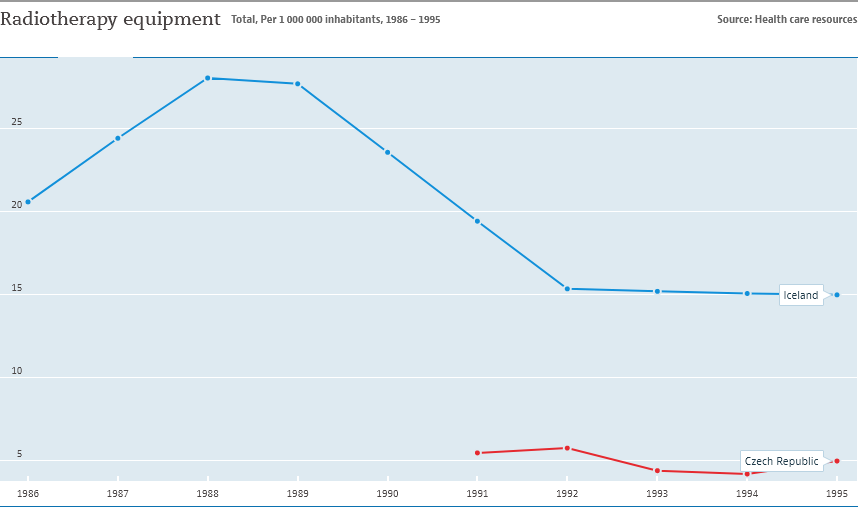Identify some key points in this picture. In 1995, Iceland's data was significantly larger than that of the Czech Republic. Specifically, the size of Iceland's data was approximately three times that of the Czech Republic. The blue line represents Iceland. 